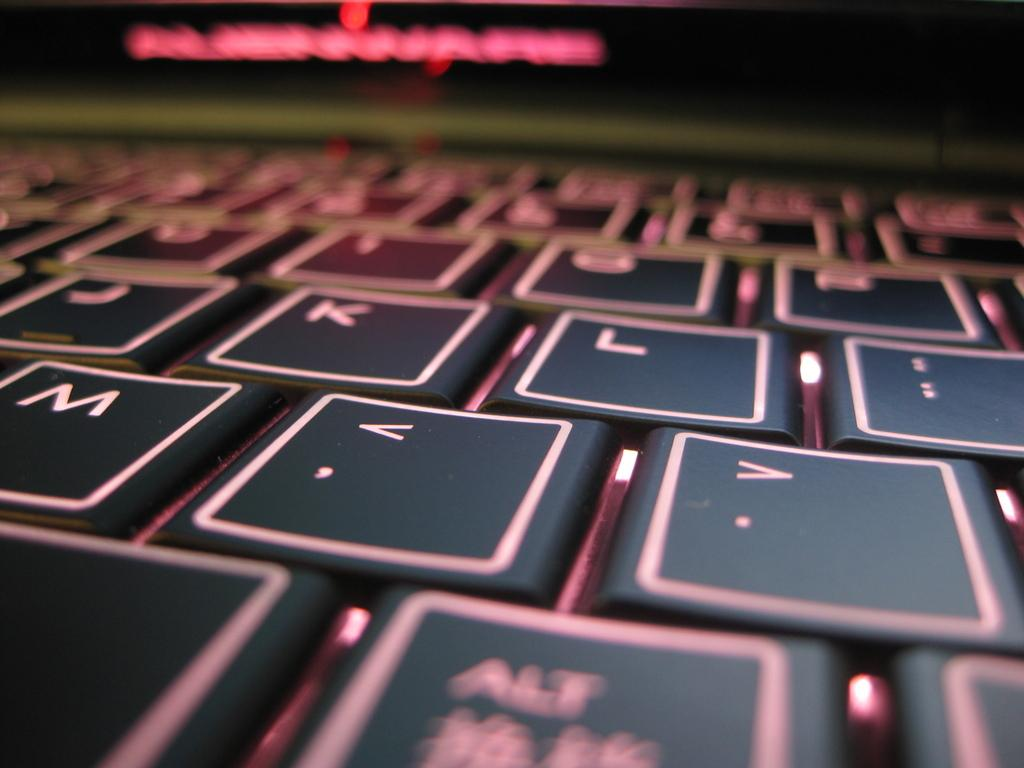What is the main object in the image? There is a keyboard in the image. What color are the keys on the keyboard? The keys on the keyboard are black in color. Can you describe any other elements in the image? There is a red colored light in the image. How does the keyboard fold in the image? The keyboard does not fold in the image; it is a standard, non-foldable keyboard. What effect does the red light have on the keyboard? The provided facts do not mention any effect the red light has on the keyboard, so we cannot determine its impact from the information given. 